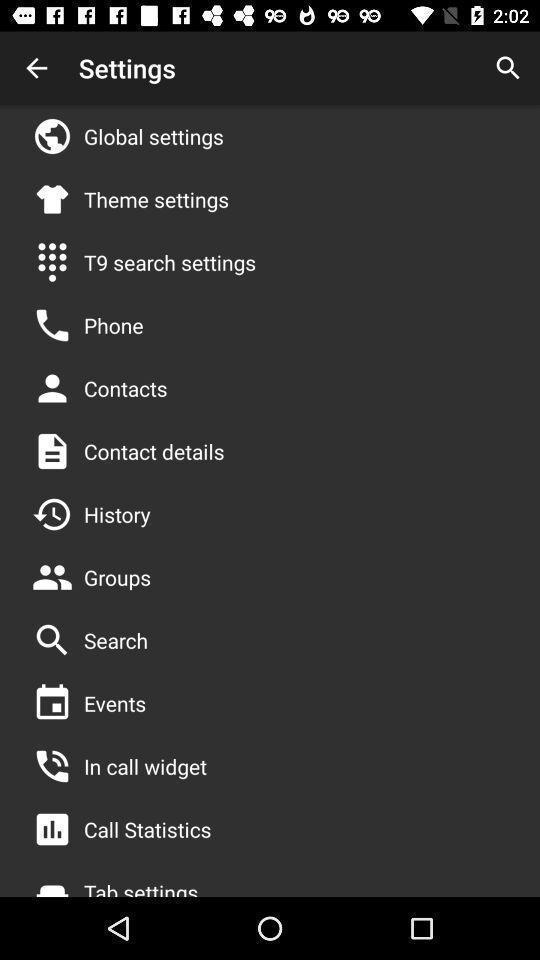Describe the content in this image. Screen shows list of settings in application. 